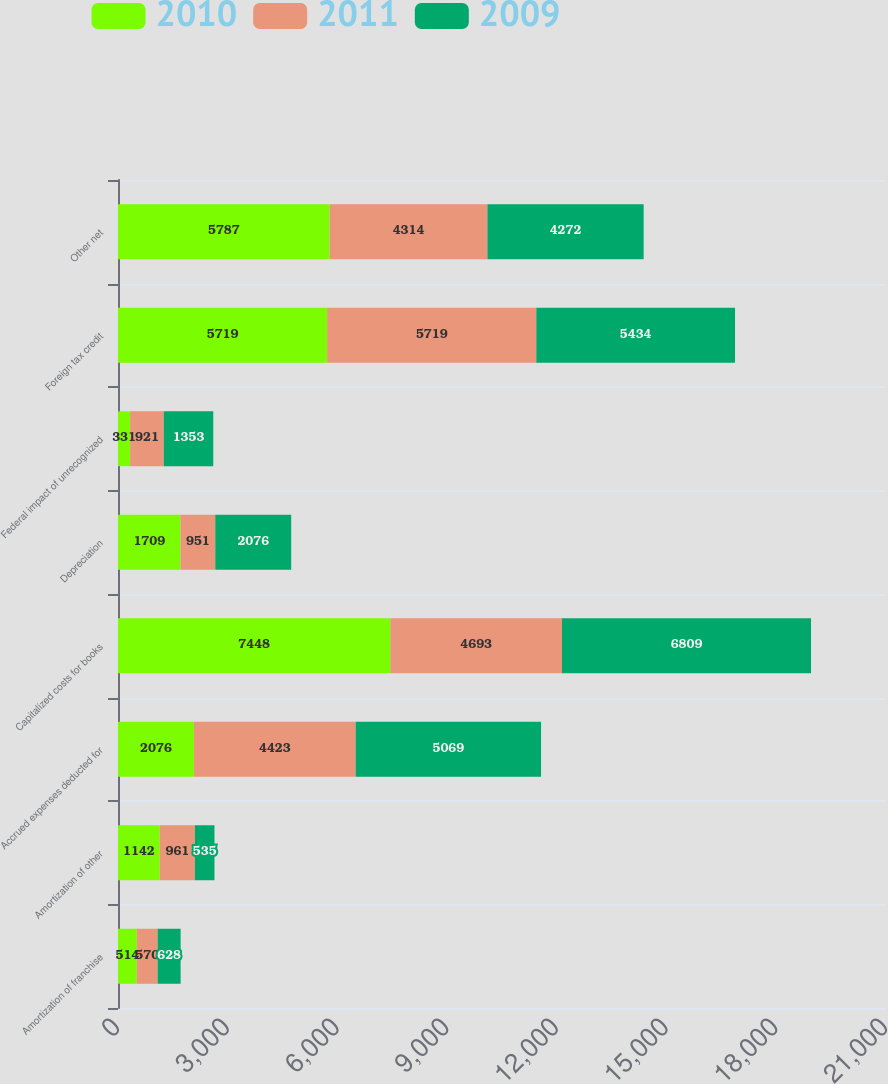<chart> <loc_0><loc_0><loc_500><loc_500><stacked_bar_chart><ecel><fcel>Amortization of franchise<fcel>Amortization of other<fcel>Accrued expenses deducted for<fcel>Capitalized costs for books<fcel>Depreciation<fcel>Federal impact of unrecognized<fcel>Foreign tax credit<fcel>Other net<nl><fcel>2010<fcel>514<fcel>1142<fcel>2076<fcel>7448<fcel>1709<fcel>331<fcel>5719<fcel>5787<nl><fcel>2011<fcel>570<fcel>961<fcel>4423<fcel>4693<fcel>951<fcel>921<fcel>5719<fcel>4314<nl><fcel>2009<fcel>628<fcel>535<fcel>5069<fcel>6809<fcel>2076<fcel>1353<fcel>5434<fcel>4272<nl></chart> 